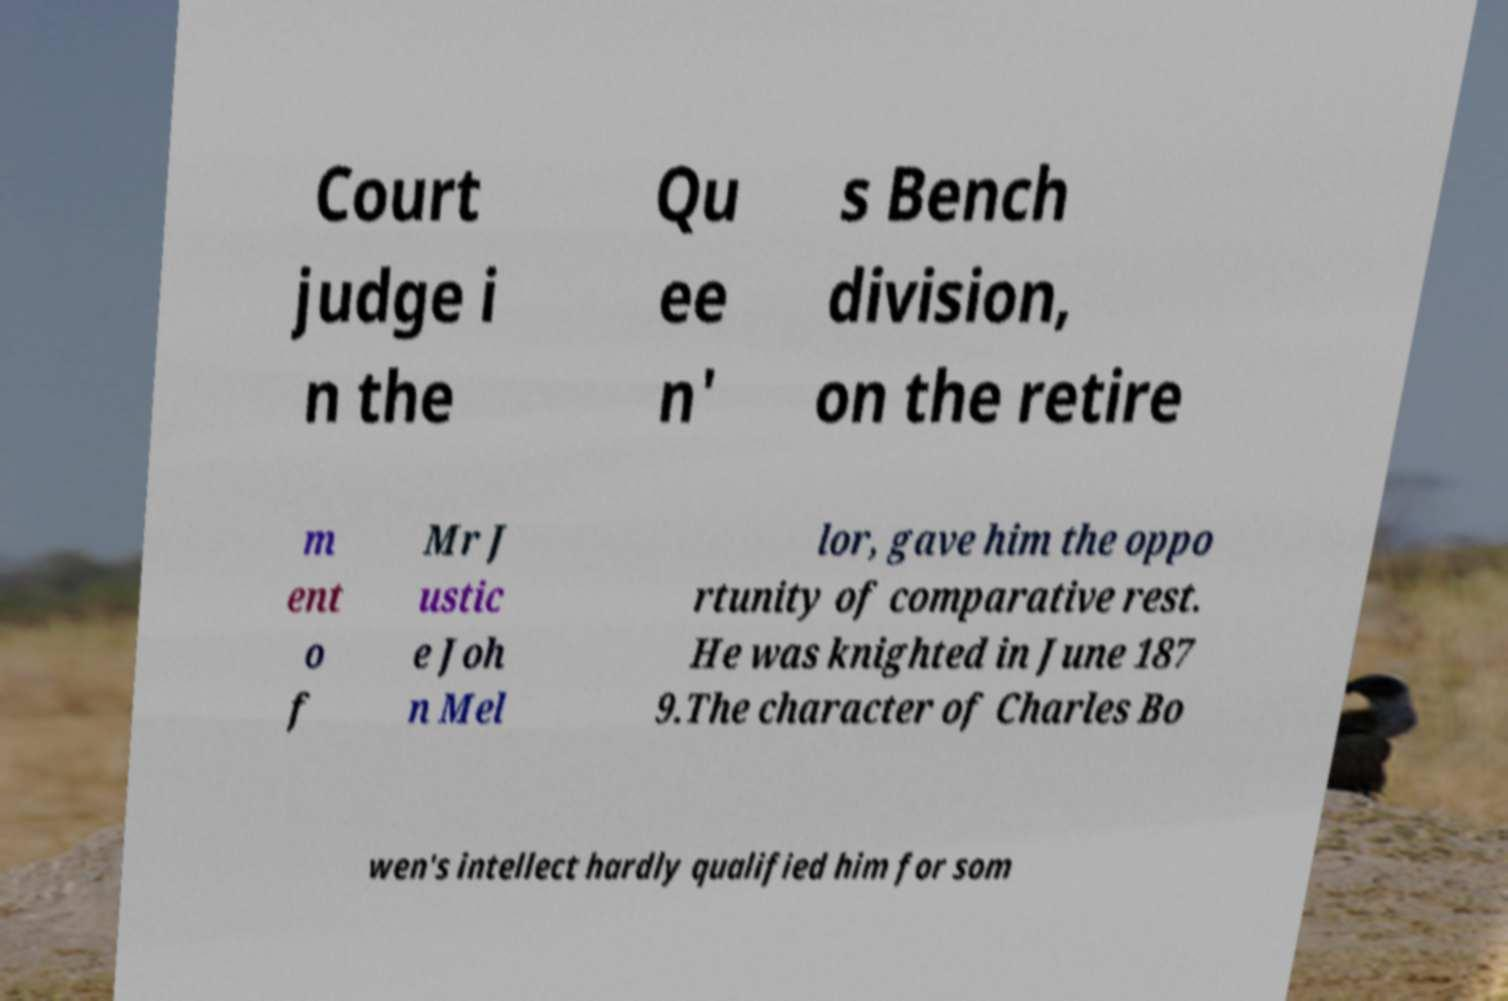I need the written content from this picture converted into text. Can you do that? Court judge i n the Qu ee n' s Bench division, on the retire m ent o f Mr J ustic e Joh n Mel lor, gave him the oppo rtunity of comparative rest. He was knighted in June 187 9.The character of Charles Bo wen's intellect hardly qualified him for som 